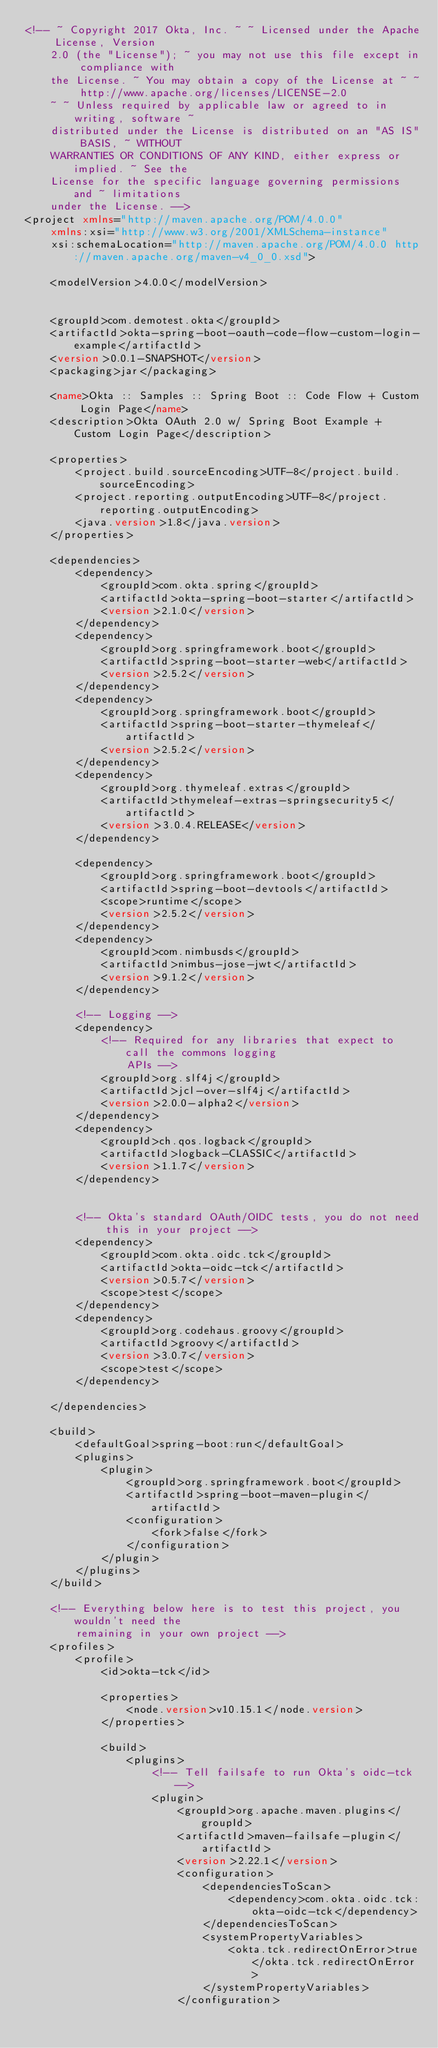<code> <loc_0><loc_0><loc_500><loc_500><_XML_><!-- ~ Copyright 2017 Okta, Inc. ~ ~ Licensed under the Apache License, Version 
	2.0 (the "License"); ~ you may not use this file except in compliance with 
	the License. ~ You may obtain a copy of the License at ~ ~ http://www.apache.org/licenses/LICENSE-2.0 
	~ ~ Unless required by applicable law or agreed to in writing, software ~ 
	distributed under the License is distributed on an "AS IS" BASIS, ~ WITHOUT 
	WARRANTIES OR CONDITIONS OF ANY KIND, either express or implied. ~ See the 
	License for the specific language governing permissions and ~ limitations 
	under the License. -->
<project xmlns="http://maven.apache.org/POM/4.0.0"
	xmlns:xsi="http://www.w3.org/2001/XMLSchema-instance"
	xsi:schemaLocation="http://maven.apache.org/POM/4.0.0 http://maven.apache.org/maven-v4_0_0.xsd">

	<modelVersion>4.0.0</modelVersion>


	<groupId>com.demotest.okta</groupId>
	<artifactId>okta-spring-boot-oauth-code-flow-custom-login-example</artifactId>
	<version>0.0.1-SNAPSHOT</version>
	<packaging>jar</packaging>

	<name>Okta :: Samples :: Spring Boot :: Code Flow + Custom Login Page</name>
	<description>Okta OAuth 2.0 w/ Spring Boot Example + Custom Login Page</description>

	<properties>
		<project.build.sourceEncoding>UTF-8</project.build.sourceEncoding>
		<project.reporting.outputEncoding>UTF-8</project.reporting.outputEncoding>
		<java.version>1.8</java.version>
	</properties>

	<dependencies>
		<dependency>
			<groupId>com.okta.spring</groupId>
			<artifactId>okta-spring-boot-starter</artifactId>
			<version>2.1.0</version>
		</dependency>
		<dependency>
			<groupId>org.springframework.boot</groupId>
			<artifactId>spring-boot-starter-web</artifactId>
			<version>2.5.2</version>
		</dependency>
		<dependency>
			<groupId>org.springframework.boot</groupId>
			<artifactId>spring-boot-starter-thymeleaf</artifactId>
			<version>2.5.2</version>
		</dependency>
		<dependency>
			<groupId>org.thymeleaf.extras</groupId>
			<artifactId>thymeleaf-extras-springsecurity5</artifactId>
			<version>3.0.4.RELEASE</version>
		</dependency>

		<dependency>
			<groupId>org.springframework.boot</groupId>
			<artifactId>spring-boot-devtools</artifactId>
			<scope>runtime</scope>
			<version>2.5.2</version>
		</dependency>
		<dependency>
			<groupId>com.nimbusds</groupId>
			<artifactId>nimbus-jose-jwt</artifactId>
			<version>9.1.2</version>
		</dependency>

		<!-- Logging -->
		<dependency>
			<!-- Required for any libraries that expect to call the commons logging 
				APIs -->
			<groupId>org.slf4j</groupId>
			<artifactId>jcl-over-slf4j</artifactId>
			<version>2.0.0-alpha2</version>
		</dependency>
		<dependency>
			<groupId>ch.qos.logback</groupId>
			<artifactId>logback-CLASSIC</artifactId>
			<version>1.1.7</version>
		</dependency>


		<!-- Okta's standard OAuth/OIDC tests, you do not need this in your project -->
		<dependency>
			<groupId>com.okta.oidc.tck</groupId>
			<artifactId>okta-oidc-tck</artifactId>
			<version>0.5.7</version>
			<scope>test</scope>
		</dependency>
		<dependency>
			<groupId>org.codehaus.groovy</groupId>
			<artifactId>groovy</artifactId>
			<version>3.0.7</version>
			<scope>test</scope>
		</dependency>

	</dependencies>

	<build>
		<defaultGoal>spring-boot:run</defaultGoal>
		<plugins>
			<plugin>
				<groupId>org.springframework.boot</groupId>
				<artifactId>spring-boot-maven-plugin</artifactId>
				<configuration>
					<fork>false</fork>
				</configuration>
			</plugin>
		</plugins>
	</build>

	<!-- Everything below here is to test this project, you wouldn't need the 
		remaining in your own project -->
	<profiles>
		<profile>
			<id>okta-tck</id>

			<properties>
				<node.version>v10.15.1</node.version>
			</properties>

			<build>
				<plugins>
					<!-- Tell failsafe to run Okta's oidc-tck -->
					<plugin>
						<groupId>org.apache.maven.plugins</groupId>
						<artifactId>maven-failsafe-plugin</artifactId>
						<version>2.22.1</version>
						<configuration>
							<dependenciesToScan>
								<dependency>com.okta.oidc.tck:okta-oidc-tck</dependency>
							</dependenciesToScan>
							<systemPropertyVariables>
								<okta.tck.redirectOnError>true</okta.tck.redirectOnError>
							</systemPropertyVariables>
						</configuration></code> 